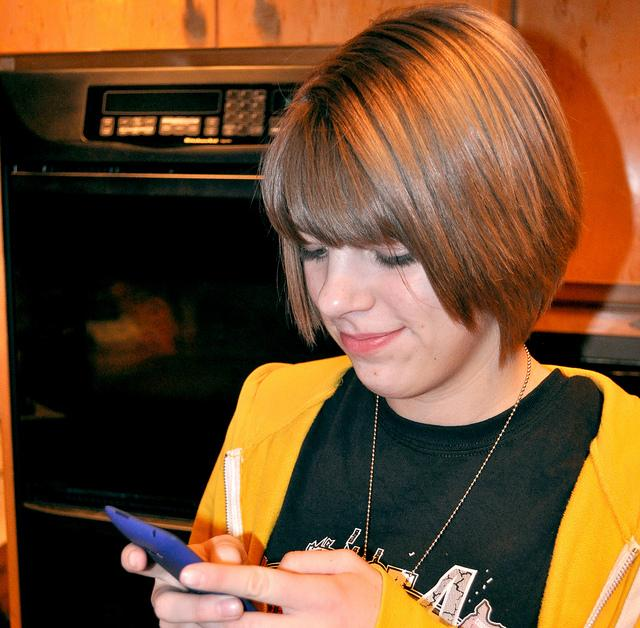What is she doing? texting 